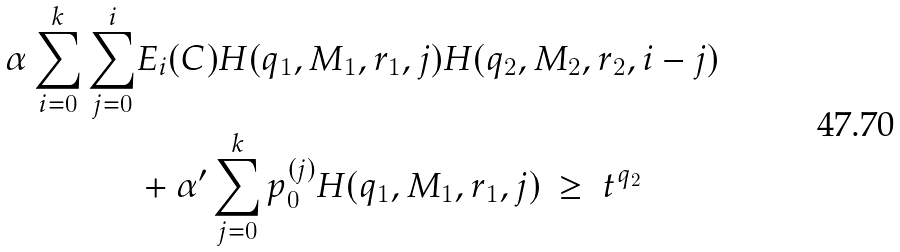Convert formula to latex. <formula><loc_0><loc_0><loc_500><loc_500>\alpha \sum _ { i = 0 } ^ { k } \sum _ { j = 0 } ^ { i } & E _ { i } ( C ) H ( q _ { 1 } , M _ { 1 } , r _ { 1 } , j ) H ( q _ { 2 } , M _ { 2 } , r _ { 2 } , i - j ) \\ & + \alpha ^ { \prime } \sum _ { j = 0 } ^ { k } p _ { 0 } ^ { ( j ) } H ( q _ { 1 } , M _ { 1 } , r _ { 1 } , j ) \ \geq \ t ^ { q _ { 2 } }</formula> 